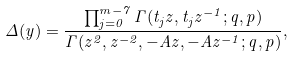<formula> <loc_0><loc_0><loc_500><loc_500>\Delta ( y ) = \frac { \prod _ { j = 0 } ^ { m - 7 } \Gamma ( t _ { j } z , t _ { j } z ^ { - 1 } ; q , p ) } { \Gamma ( z ^ { 2 } , z ^ { - 2 } , - A z , - A z ^ { - 1 } ; q , p ) } ,</formula> 